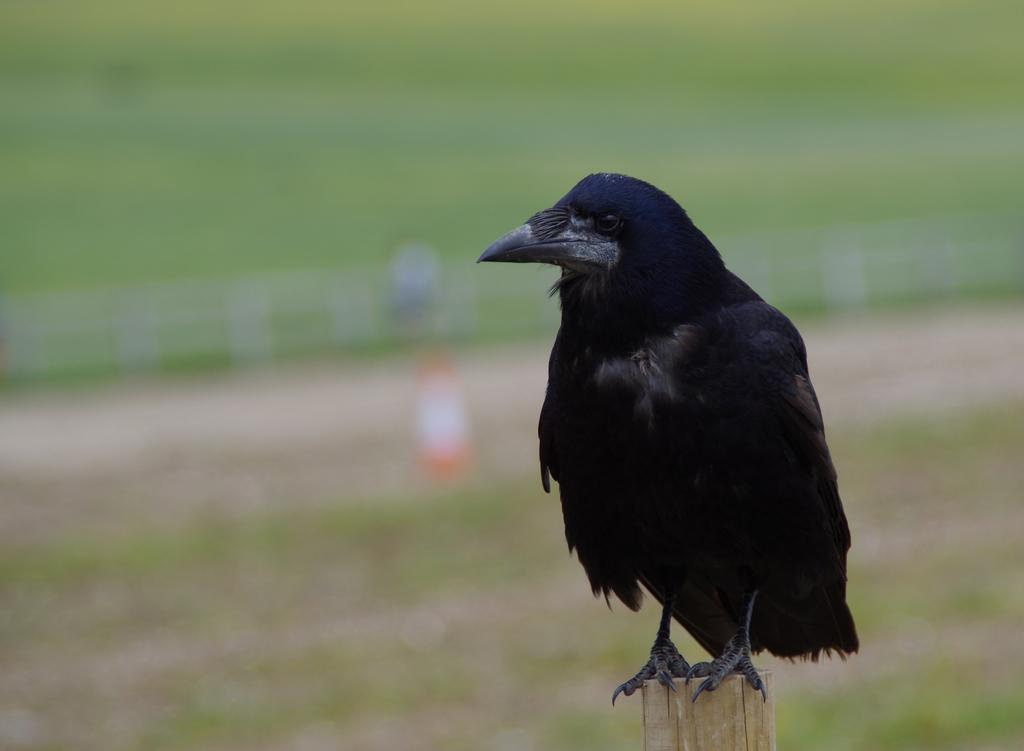What type of bird is in the image? There is a crow in the image. Where is the crow located? The crow is standing on a wooden pole. Can you describe the background of the image? The background of the image is blurred. What type of cattle can be seen grazing in the background of the image? There is no cattle present in the image; it only features a crow standing on a wooden pole with a blurred background. 